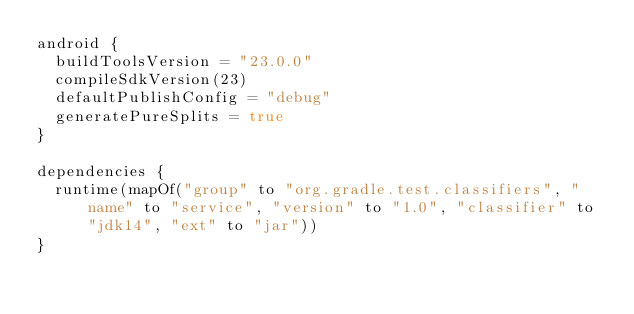Convert code to text. <code><loc_0><loc_0><loc_500><loc_500><_Kotlin_>android {
  buildToolsVersion = "23.0.0"
  compileSdkVersion(23)
  defaultPublishConfig = "debug"
  generatePureSplits = true
}

dependencies {
  runtime(mapOf("group" to "org.gradle.test.classifiers", "name" to "service", "version" to "1.0", "classifier" to "jdk14", "ext" to "jar"))
}
</code> 